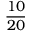Convert formula to latex. <formula><loc_0><loc_0><loc_500><loc_500>\frac { 1 0 } { 2 0 }</formula> 